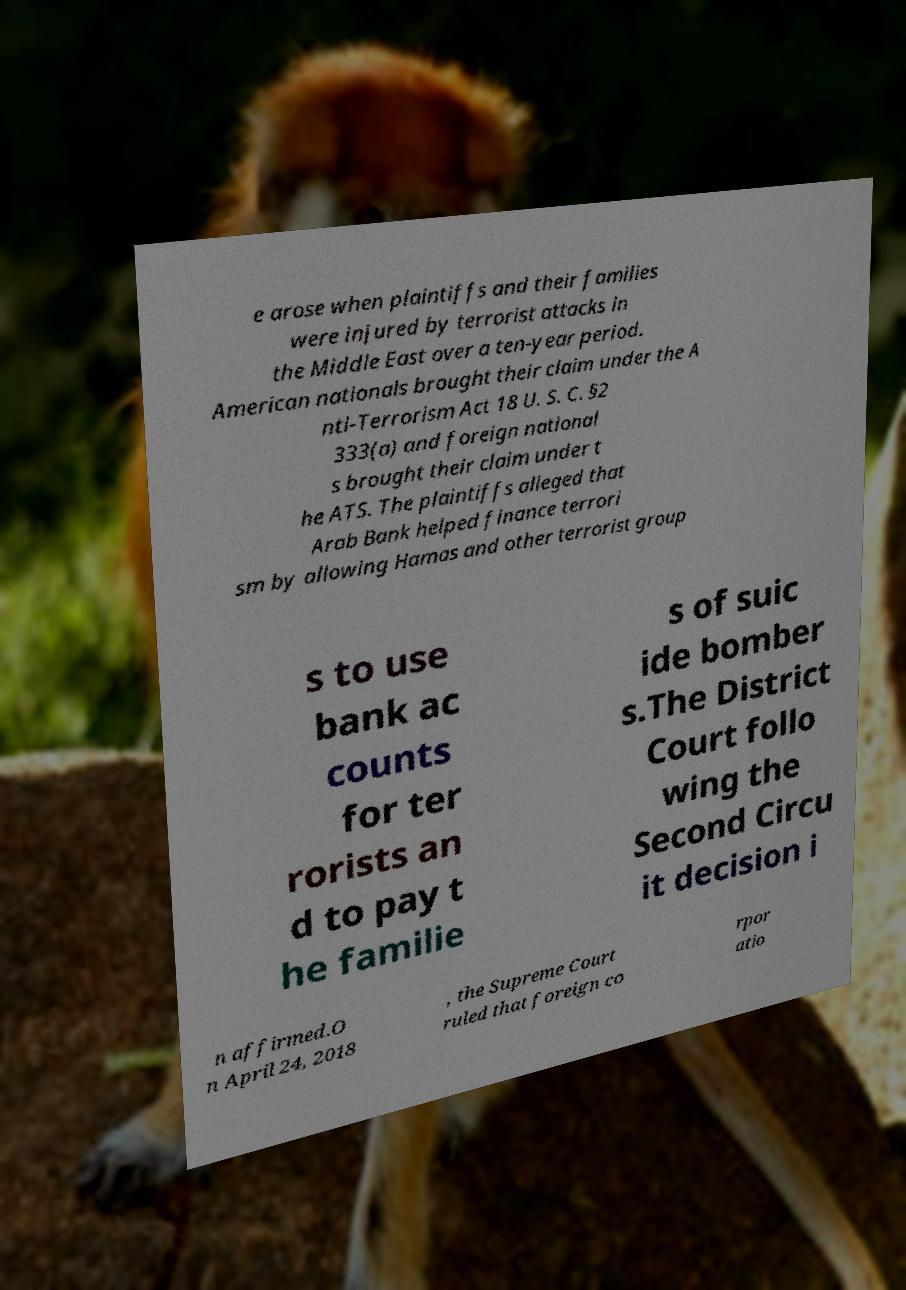I need the written content from this picture converted into text. Can you do that? e arose when plaintiffs and their families were injured by terrorist attacks in the Middle East over a ten-year period. American nationals brought their claim under the A nti-Terrorism Act 18 U. S. C. §2 333(a) and foreign national s brought their claim under t he ATS. The plaintiffs alleged that Arab Bank helped finance terrori sm by allowing Hamas and other terrorist group s to use bank ac counts for ter rorists an d to pay t he familie s of suic ide bomber s.The District Court follo wing the Second Circu it decision i n affirmed.O n April 24, 2018 , the Supreme Court ruled that foreign co rpor atio 